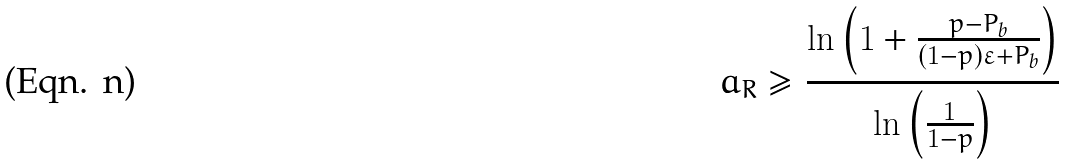<formula> <loc_0><loc_0><loc_500><loc_500>a _ { R } \geq \frac { \ln \left ( 1 + \frac { p - P _ { \text {b} } } { ( 1 - p ) \varepsilon + P _ { \text {b} } } \right ) } { \ln \left ( \frac { 1 } { 1 - p } \right ) }</formula> 